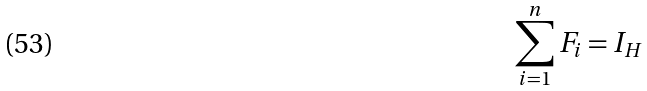Convert formula to latex. <formula><loc_0><loc_0><loc_500><loc_500>\sum _ { i = 1 } ^ { n } F _ { i } = I _ { H }</formula> 